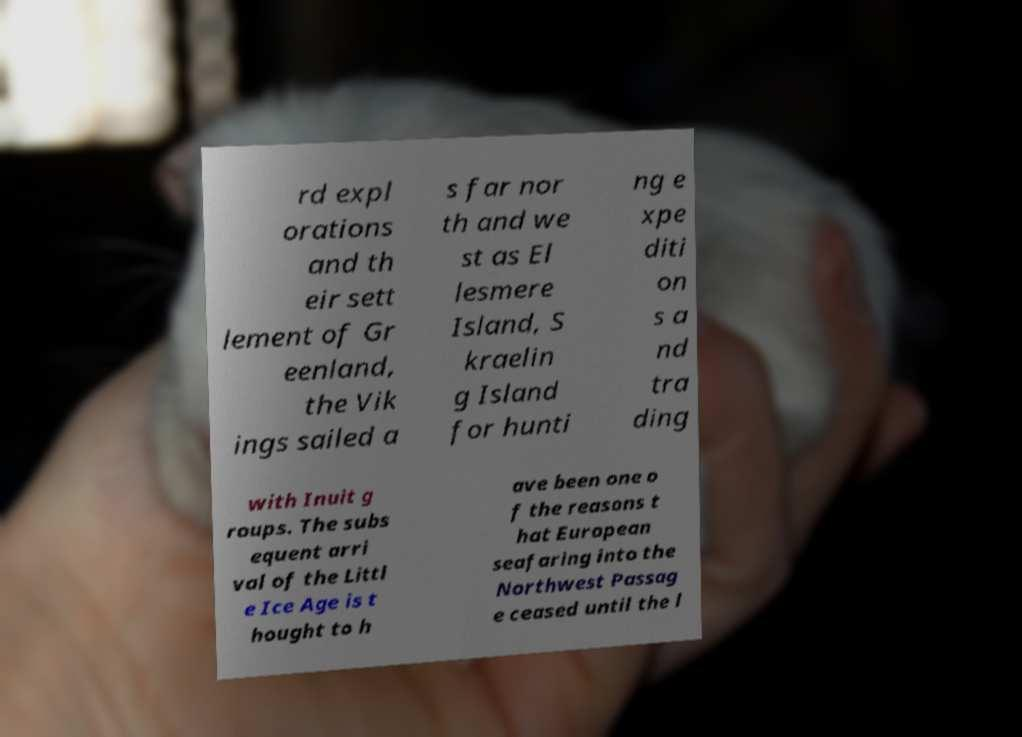Can you read and provide the text displayed in the image?This photo seems to have some interesting text. Can you extract and type it out for me? rd expl orations and th eir sett lement of Gr eenland, the Vik ings sailed a s far nor th and we st as El lesmere Island, S kraelin g Island for hunti ng e xpe diti on s a nd tra ding with Inuit g roups. The subs equent arri val of the Littl e Ice Age is t hought to h ave been one o f the reasons t hat European seafaring into the Northwest Passag e ceased until the l 